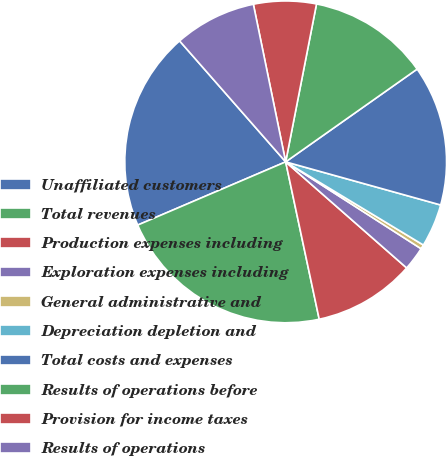Convert chart to OTSL. <chart><loc_0><loc_0><loc_500><loc_500><pie_chart><fcel>Unaffiliated customers<fcel>Total revenues<fcel>Production expenses including<fcel>Exploration expenses including<fcel>General administrative and<fcel>Depreciation depletion and<fcel>Total costs and expenses<fcel>Results of operations before<fcel>Provision for income taxes<fcel>Results of operations<nl><fcel>19.97%<fcel>21.92%<fcel>10.2%<fcel>2.38%<fcel>0.43%<fcel>4.33%<fcel>14.1%<fcel>12.15%<fcel>6.29%<fcel>8.24%<nl></chart> 